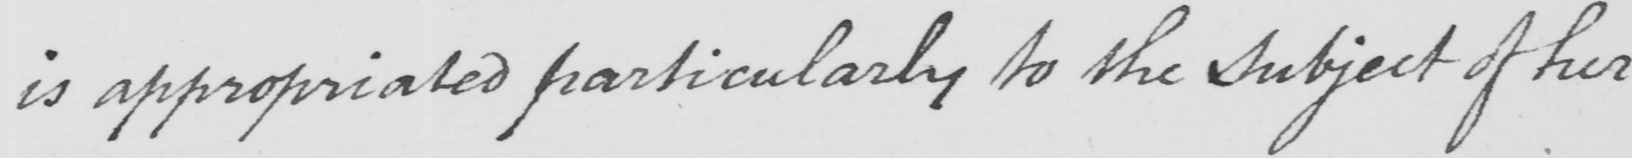Please provide the text content of this handwritten line. is appropriated particularly to the subject of her 